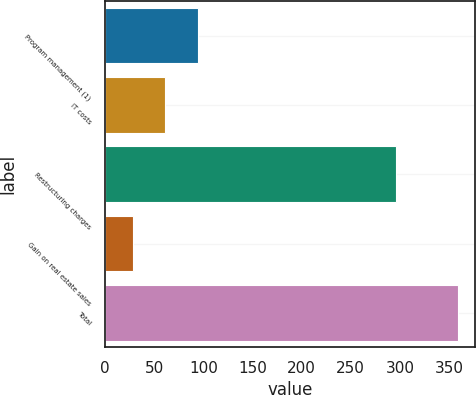Convert chart. <chart><loc_0><loc_0><loc_500><loc_500><bar_chart><fcel>Program management (1)<fcel>IT costs<fcel>Restructuring charges<fcel>Gain on real estate sales<fcel>Total<nl><fcel>94.2<fcel>61.1<fcel>296<fcel>28<fcel>359<nl></chart> 